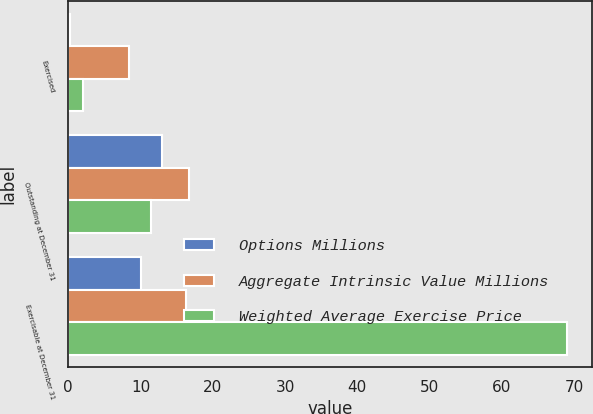Convert chart to OTSL. <chart><loc_0><loc_0><loc_500><loc_500><stacked_bar_chart><ecel><fcel>Exercised<fcel>Outstanding at December 31<fcel>Exercisable at December 31<nl><fcel>Options Millions<fcel>0.2<fcel>13<fcel>10<nl><fcel>Aggregate Intrinsic Value Millions<fcel>8.46<fcel>16.73<fcel>16.32<nl><fcel>Weighted Average Exercise Price<fcel>2<fcel>11.5<fcel>69<nl></chart> 